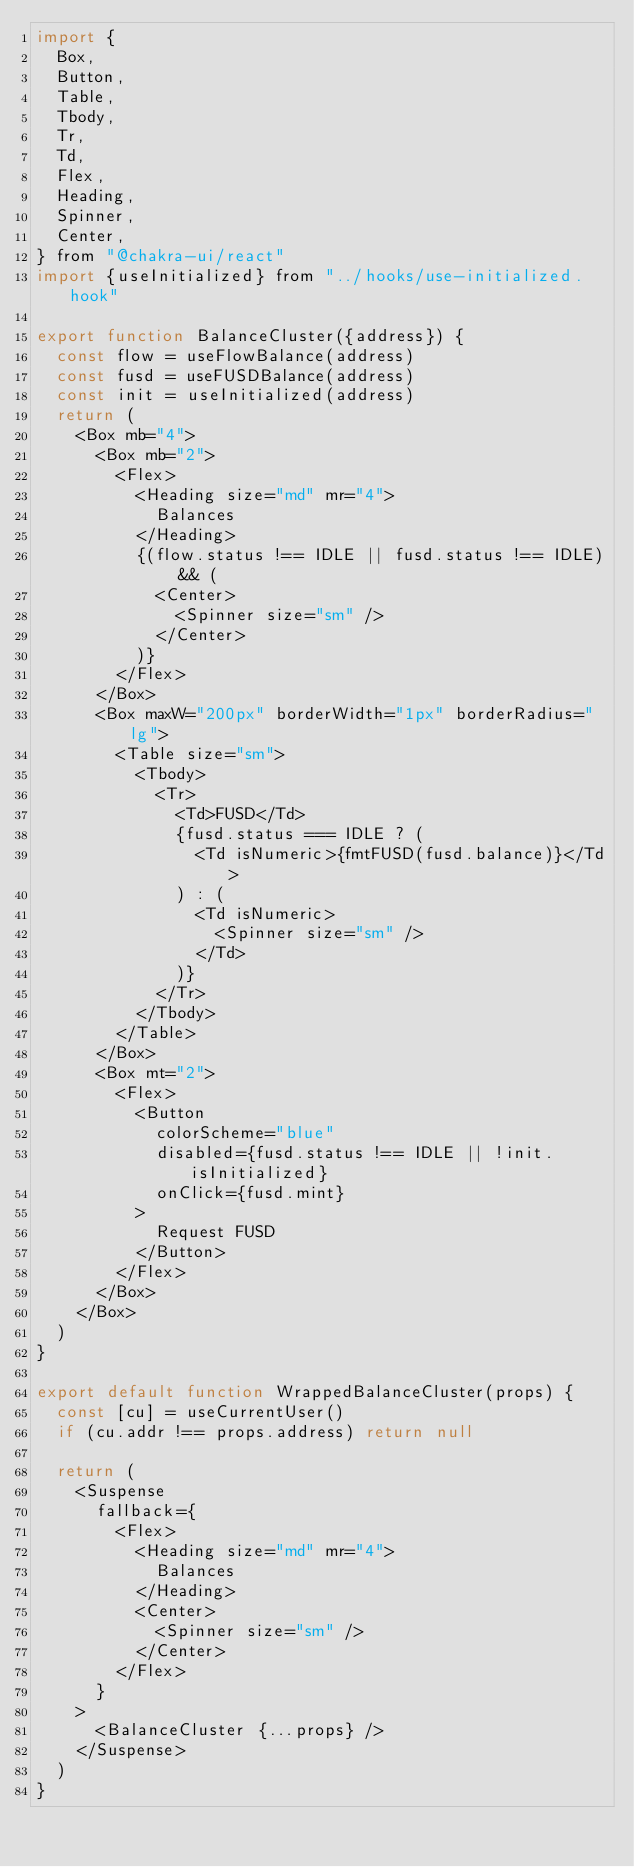Convert code to text. <code><loc_0><loc_0><loc_500><loc_500><_JavaScript_>import {
  Box,
  Button,
  Table,
  Tbody,
  Tr,
  Td,
  Flex,
  Heading,
  Spinner,
  Center,
} from "@chakra-ui/react"
import {useInitialized} from "../hooks/use-initialized.hook"

export function BalanceCluster({address}) {
  const flow = useFlowBalance(address)
  const fusd = useFUSDBalance(address)
  const init = useInitialized(address)
  return (
    <Box mb="4">
      <Box mb="2">
        <Flex>
          <Heading size="md" mr="4">
            Balances
          </Heading>
          {(flow.status !== IDLE || fusd.status !== IDLE) && (
            <Center>
              <Spinner size="sm" />
            </Center>
          )}
        </Flex>
      </Box>
      <Box maxW="200px" borderWidth="1px" borderRadius="lg">
        <Table size="sm">
          <Tbody>
            <Tr>
              <Td>FUSD</Td>
              {fusd.status === IDLE ? (
                <Td isNumeric>{fmtFUSD(fusd.balance)}</Td>
              ) : (
                <Td isNumeric>
                  <Spinner size="sm" />
                </Td>
              )}
            </Tr>
          </Tbody>
        </Table>
      </Box>
      <Box mt="2">
        <Flex>
          <Button
            colorScheme="blue"
            disabled={fusd.status !== IDLE || !init.isInitialized}
            onClick={fusd.mint}
          >
            Request FUSD
          </Button>
        </Flex>
      </Box>
    </Box>
  )
}

export default function WrappedBalanceCluster(props) {
  const [cu] = useCurrentUser()
  if (cu.addr !== props.address) return null

  return (
    <Suspense
      fallback={
        <Flex>
          <Heading size="md" mr="4">
            Balances
          </Heading>
          <Center>
            <Spinner size="sm" />
          </Center>
        </Flex>
      }
    >
      <BalanceCluster {...props} />
    </Suspense>
  )
}
</code> 